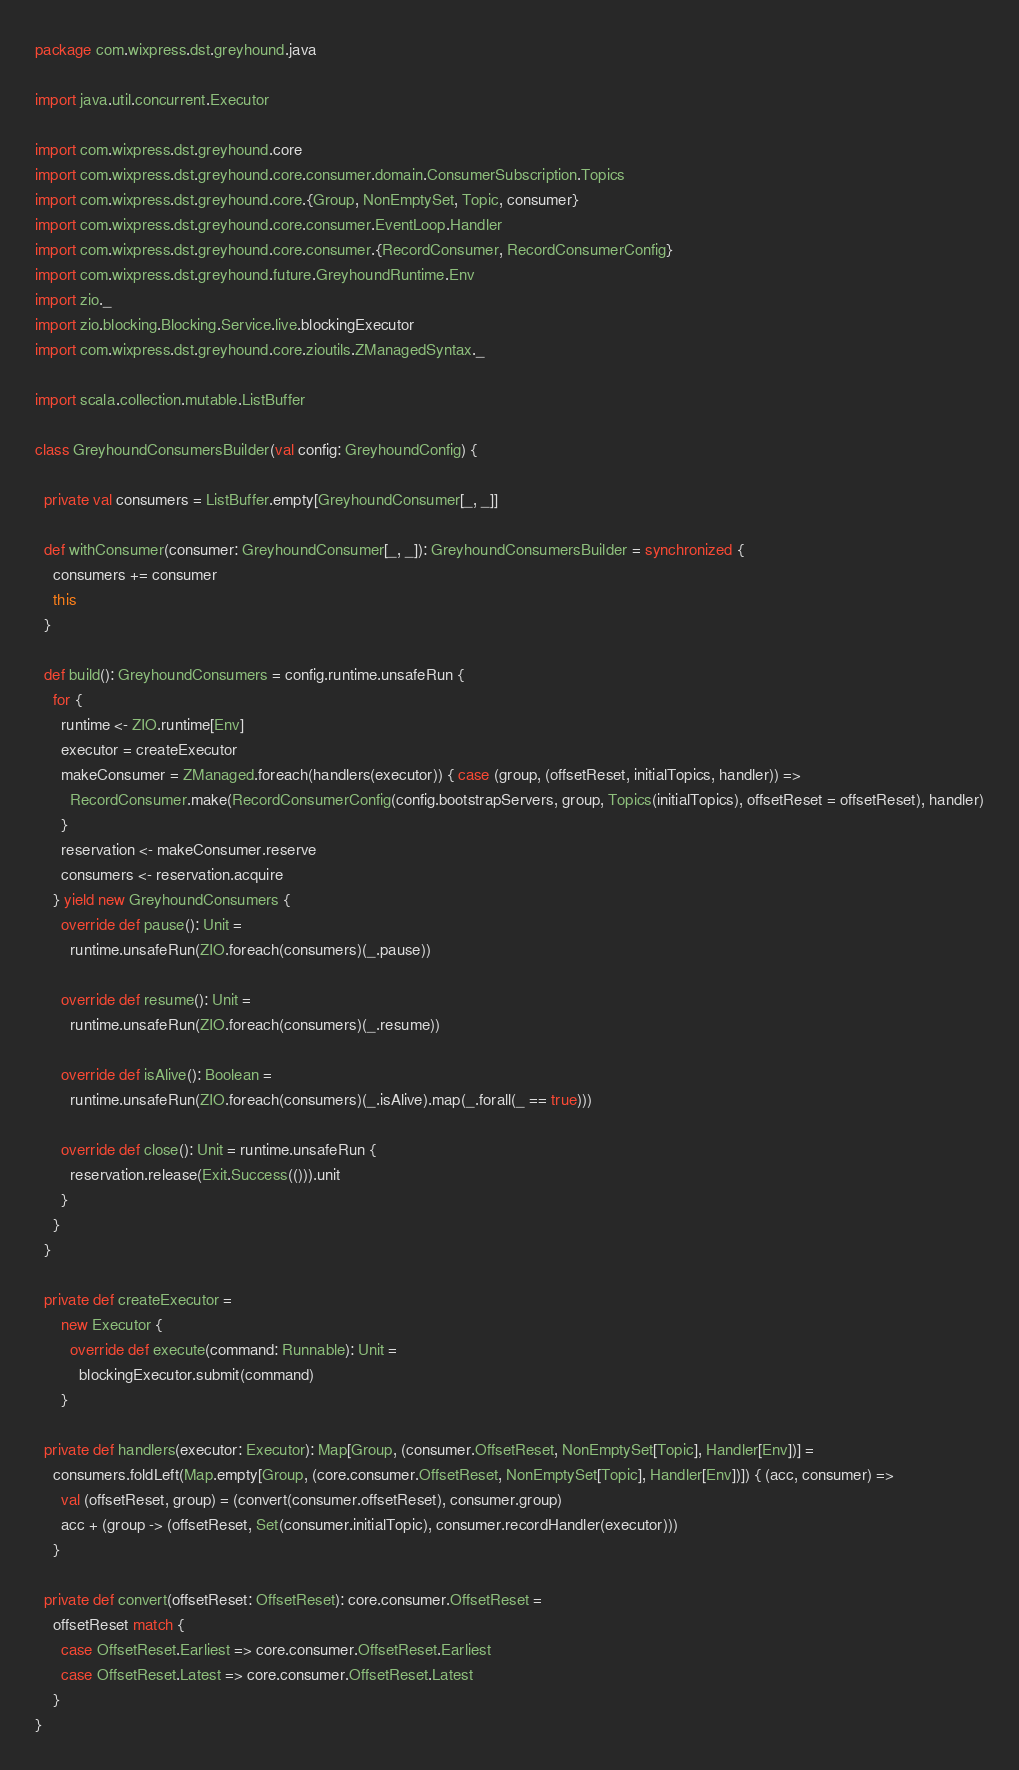<code> <loc_0><loc_0><loc_500><loc_500><_Scala_>package com.wixpress.dst.greyhound.java

import java.util.concurrent.Executor

import com.wixpress.dst.greyhound.core
import com.wixpress.dst.greyhound.core.consumer.domain.ConsumerSubscription.Topics
import com.wixpress.dst.greyhound.core.{Group, NonEmptySet, Topic, consumer}
import com.wixpress.dst.greyhound.core.consumer.EventLoop.Handler
import com.wixpress.dst.greyhound.core.consumer.{RecordConsumer, RecordConsumerConfig}
import com.wixpress.dst.greyhound.future.GreyhoundRuntime.Env
import zio._
import zio.blocking.Blocking.Service.live.blockingExecutor
import com.wixpress.dst.greyhound.core.zioutils.ZManagedSyntax._

import scala.collection.mutable.ListBuffer

class GreyhoundConsumersBuilder(val config: GreyhoundConfig) {

  private val consumers = ListBuffer.empty[GreyhoundConsumer[_, _]]

  def withConsumer(consumer: GreyhoundConsumer[_, _]): GreyhoundConsumersBuilder = synchronized {
    consumers += consumer
    this
  }

  def build(): GreyhoundConsumers = config.runtime.unsafeRun {
    for {
      runtime <- ZIO.runtime[Env]
      executor = createExecutor
      makeConsumer = ZManaged.foreach(handlers(executor)) { case (group, (offsetReset, initialTopics, handler)) =>
        RecordConsumer.make(RecordConsumerConfig(config.bootstrapServers, group, Topics(initialTopics), offsetReset = offsetReset), handler)
      }
      reservation <- makeConsumer.reserve
      consumers <- reservation.acquire
    } yield new GreyhoundConsumers {
      override def pause(): Unit =
        runtime.unsafeRun(ZIO.foreach(consumers)(_.pause))

      override def resume(): Unit =
        runtime.unsafeRun(ZIO.foreach(consumers)(_.resume))

      override def isAlive(): Boolean =
        runtime.unsafeRun(ZIO.foreach(consumers)(_.isAlive).map(_.forall(_ == true)))

      override def close(): Unit = runtime.unsafeRun {
        reservation.release(Exit.Success(())).unit
      }
    }
  }

  private def createExecutor =
      new Executor {
        override def execute(command: Runnable): Unit =
          blockingExecutor.submit(command)
      }

  private def handlers(executor: Executor): Map[Group, (consumer.OffsetReset, NonEmptySet[Topic], Handler[Env])] =
    consumers.foldLeft(Map.empty[Group, (core.consumer.OffsetReset, NonEmptySet[Topic], Handler[Env])]) { (acc, consumer) =>
      val (offsetReset, group) = (convert(consumer.offsetReset), consumer.group)
      acc + (group -> (offsetReset, Set(consumer.initialTopic), consumer.recordHandler(executor)))
    }

  private def convert(offsetReset: OffsetReset): core.consumer.OffsetReset =
    offsetReset match {
      case OffsetReset.Earliest => core.consumer.OffsetReset.Earliest
      case OffsetReset.Latest => core.consumer.OffsetReset.Latest
    }
}
</code> 